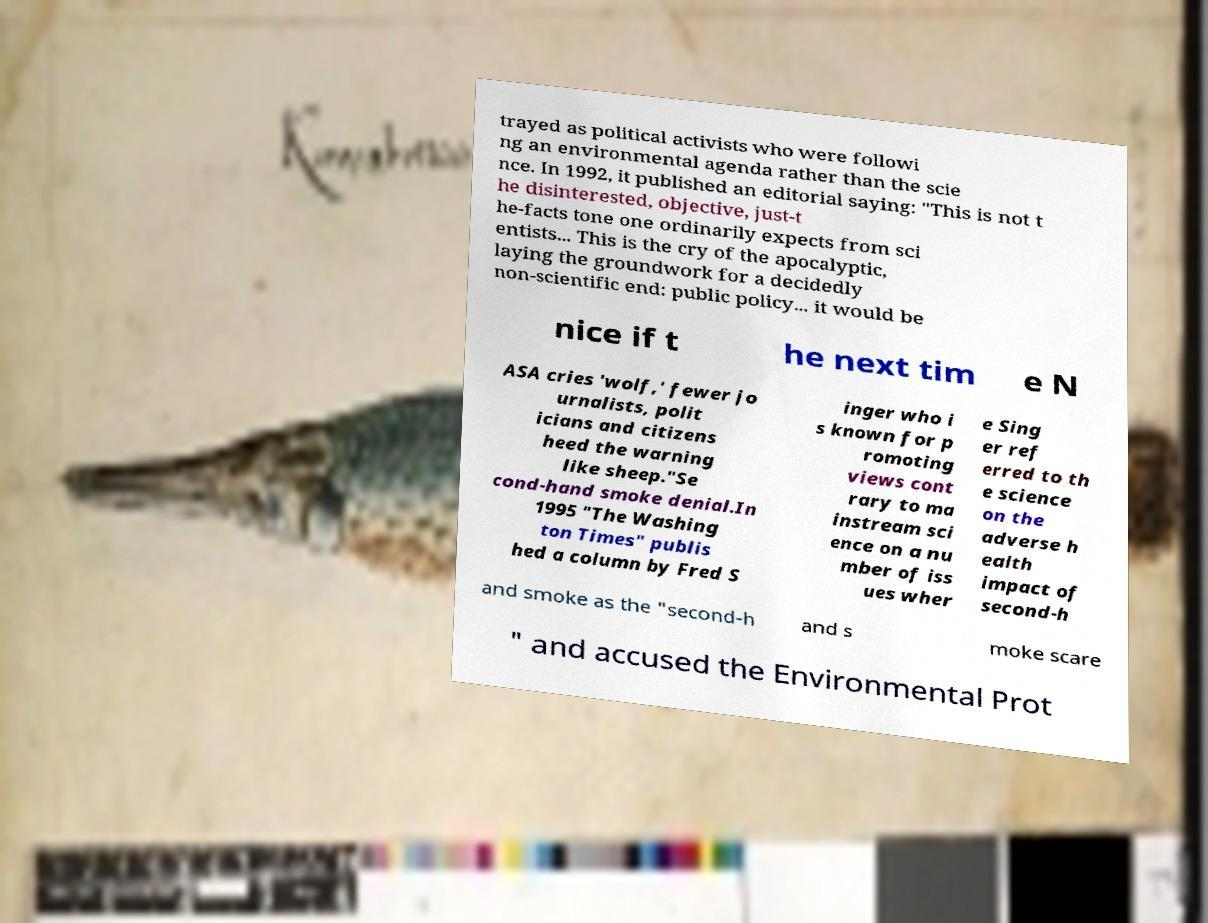I need the written content from this picture converted into text. Can you do that? trayed as political activists who were followi ng an environmental agenda rather than the scie nce. In 1992, it published an editorial saying: "This is not t he disinterested, objective, just-t he-facts tone one ordinarily expects from sci entists... This is the cry of the apocalyptic, laying the groundwork for a decidedly non-scientific end: public policy... it would be nice if t he next tim e N ASA cries 'wolf,' fewer jo urnalists, polit icians and citizens heed the warning like sheep."Se cond-hand smoke denial.In 1995 "The Washing ton Times" publis hed a column by Fred S inger who i s known for p romoting views cont rary to ma instream sci ence on a nu mber of iss ues wher e Sing er ref erred to th e science on the adverse h ealth impact of second-h and smoke as the "second-h and s moke scare " and accused the Environmental Prot 